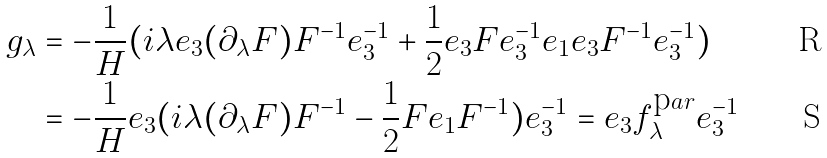Convert formula to latex. <formula><loc_0><loc_0><loc_500><loc_500>g _ { \lambda } & = - \frac { 1 } { H } ( i \lambda e _ { 3 } ( \partial _ { \lambda } F ) F ^ { - 1 } e _ { 3 } ^ { - 1 } + \frac { 1 } { 2 } e _ { 3 } F e _ { 3 } ^ { - 1 } e _ { 1 } e _ { 3 } F ^ { - 1 } e _ { 3 } ^ { - 1 } ) \\ & = - \frac { 1 } { H } e _ { 3 } ( i \lambda ( \partial _ { \lambda } F ) F ^ { - 1 } - \frac { 1 } { 2 } F e _ { 1 } F ^ { - 1 } ) e _ { 3 } ^ { - 1 } = e _ { 3 } f _ { \lambda } ^ { \mbox p a r } e _ { 3 } ^ { - 1 }</formula> 